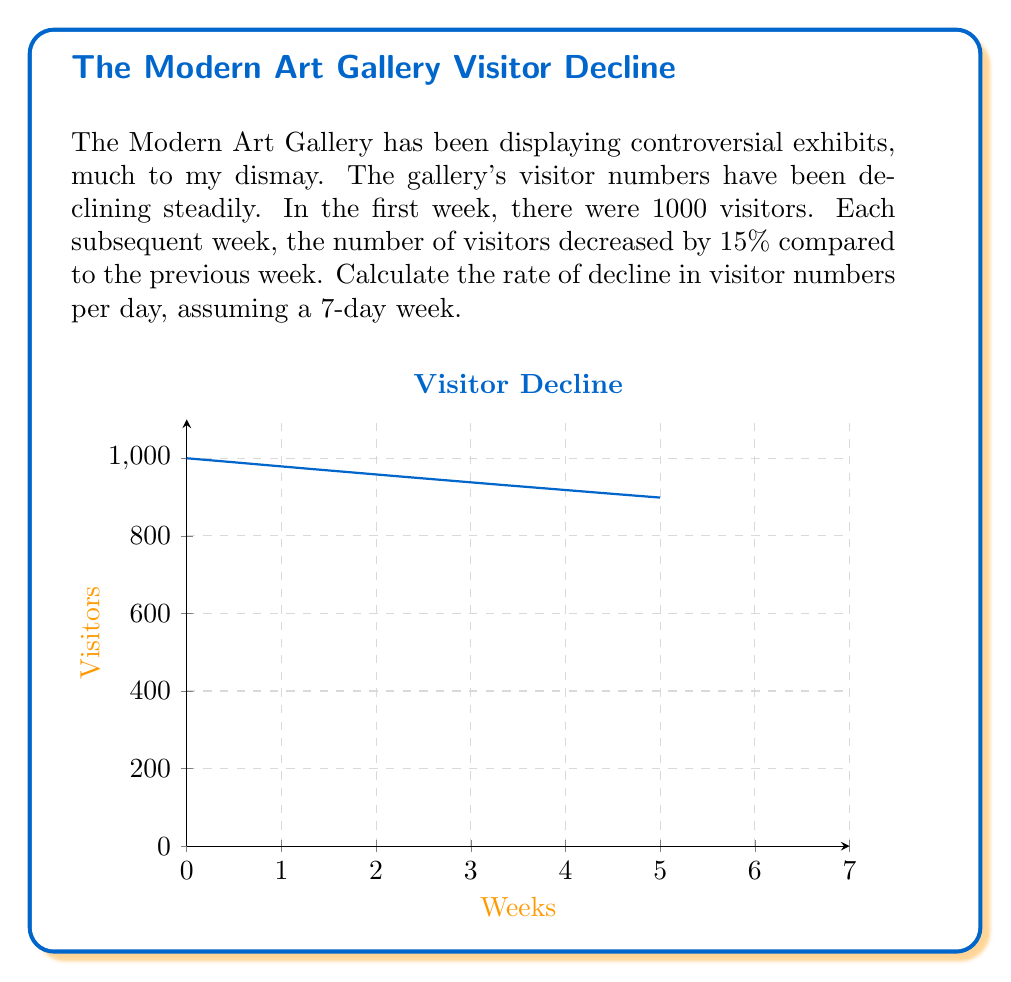Help me with this question. Let's approach this step-by-step:

1) First, we need to find the weekly rate of decline. It's given as 15% or 0.15.

2) To find the daily rate, we need to convert this weekly rate to a daily rate.

3) We can use the compound interest formula in reverse:

   $$(1+r)^7 = 1 - 0.15$$

   Where $r$ is the daily rate we're looking for, and 7 is the number of days in a week.

4) Solving for $r$:

   $$r = (1 - 0.15)^{\frac{1}{7}} - 1$$

5) Let's calculate this:

   $$r = (0.85)^{\frac{1}{7}} - 1 \approx -0.0230 \text{ or } -2.30\%$$

6) To express this as a rate of decline, we take the absolute value:

   $$\text{Rate of decline} = |-0.0230| = 0.0230 \text{ or } 2.30\%$$

Thus, the daily rate of decline is approximately 2.30%.
Answer: 2.30% per day 